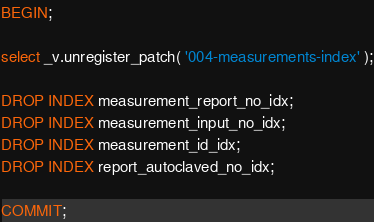Convert code to text. <code><loc_0><loc_0><loc_500><loc_500><_SQL_>BEGIN;

select _v.unregister_patch( '004-measurements-index' );

DROP INDEX measurement_report_no_idx;
DROP INDEX measurement_input_no_idx;
DROP INDEX measurement_id_idx;
DROP INDEX report_autoclaved_no_idx;

COMMIT;
</code> 